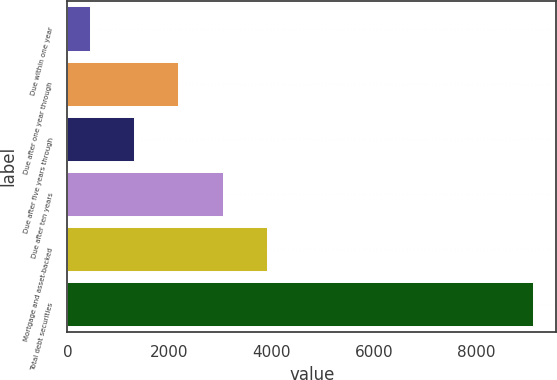<chart> <loc_0><loc_0><loc_500><loc_500><bar_chart><fcel>Due within one year<fcel>Due after one year through<fcel>Due after five years through<fcel>Due after ten years<fcel>Mortgage and asset-backed<fcel>Total debt securities<nl><fcel>439<fcel>2173.2<fcel>1306.1<fcel>3040.3<fcel>3907.4<fcel>9110<nl></chart> 